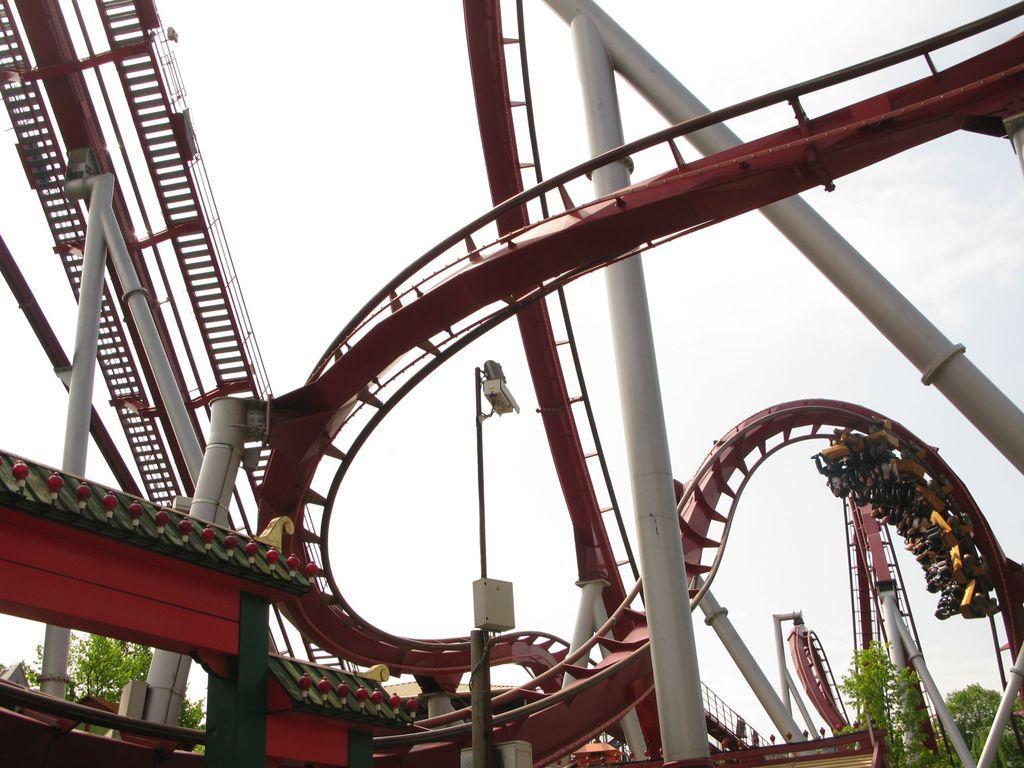Please provide a concise description of this image. In this picture there is a rollercoaster and there are group of people sitting in the vehicle and there is a pole and there is a cc camera on the pole and there are trees. At the top there is sky. 